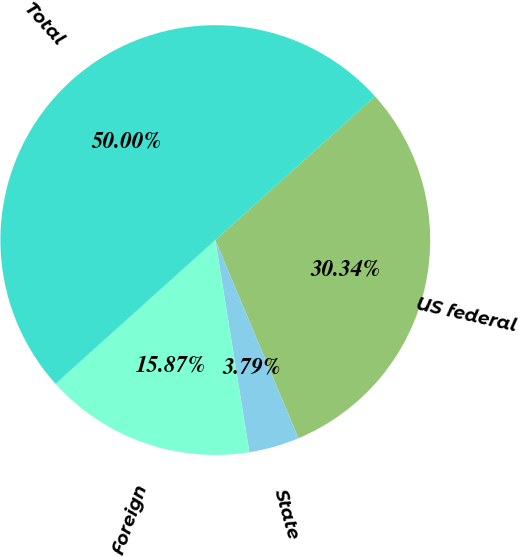<chart> <loc_0><loc_0><loc_500><loc_500><pie_chart><fcel>US federal<fcel>State<fcel>Foreign<fcel>Total<nl><fcel>30.34%<fcel>3.79%<fcel>15.87%<fcel>50.0%<nl></chart> 